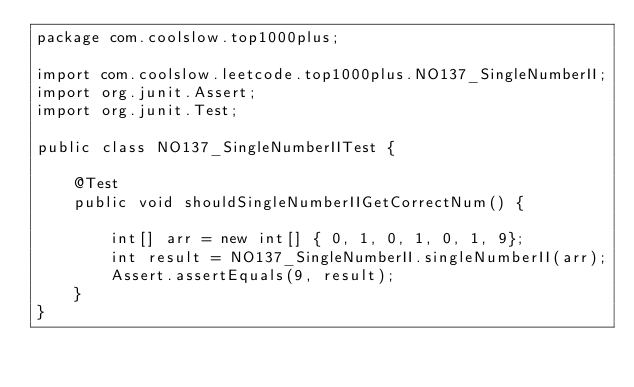<code> <loc_0><loc_0><loc_500><loc_500><_Java_>package com.coolslow.top1000plus;

import com.coolslow.leetcode.top1000plus.NO137_SingleNumberII;
import org.junit.Assert;
import org.junit.Test;

public class NO137_SingleNumberIITest {

    @Test
    public void shouldSingleNumberIIGetCorrectNum() {

        int[] arr = new int[] { 0, 1, 0, 1, 0, 1, 9};
        int result = NO137_SingleNumberII.singleNumberII(arr);
        Assert.assertEquals(9, result);
    }
}
</code> 